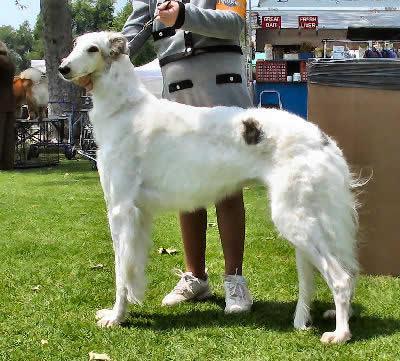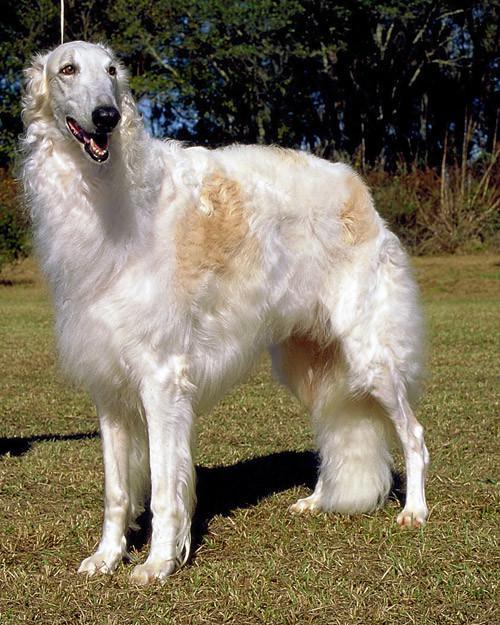The first image is the image on the left, the second image is the image on the right. Examine the images to the left and right. Is the description "There is only one dog in the left image and it is looking left." accurate? Answer yes or no. Yes. The first image is the image on the left, the second image is the image on the right. Assess this claim about the two images: "A woman's legs are seen next to dog.". Correct or not? Answer yes or no. Yes. 